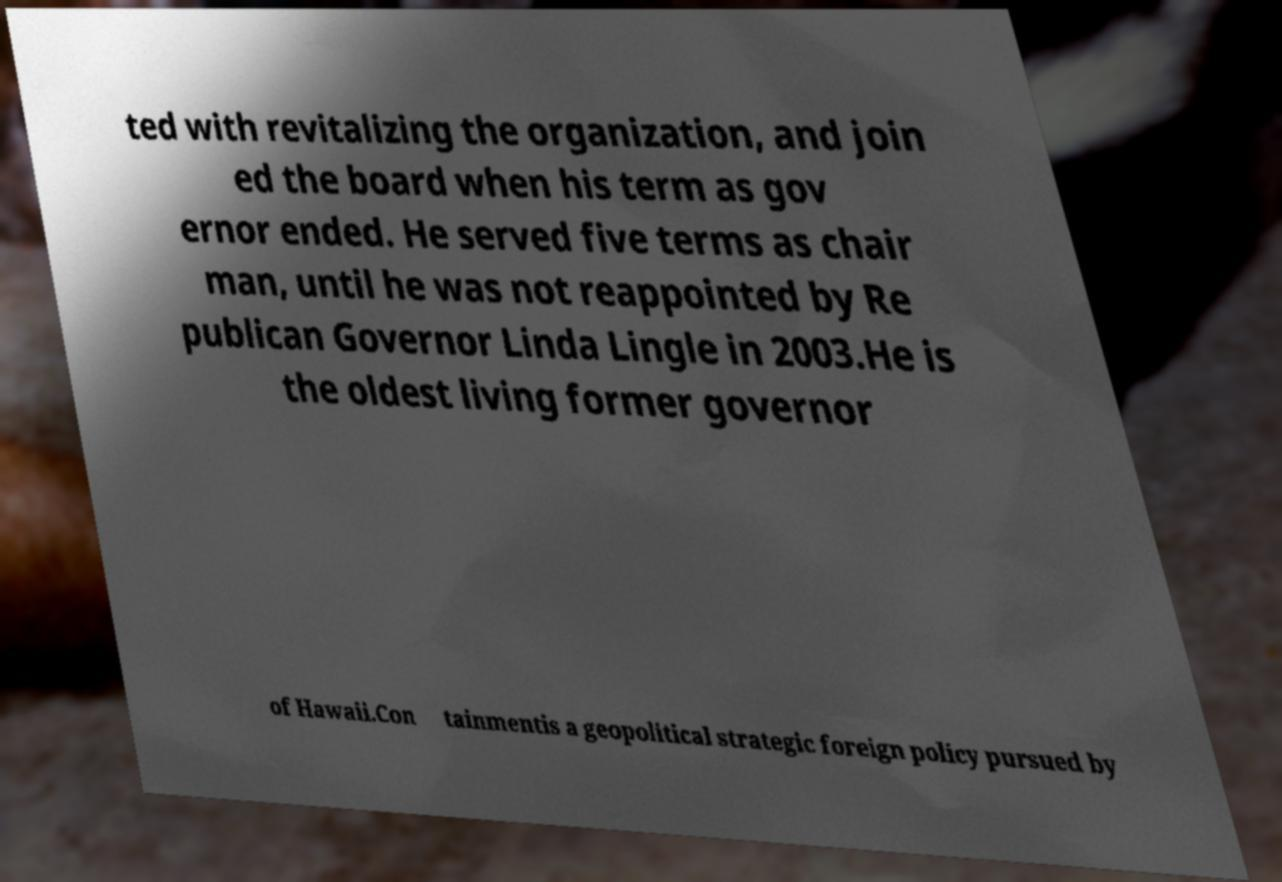For documentation purposes, I need the text within this image transcribed. Could you provide that? ted with revitalizing the organization, and join ed the board when his term as gov ernor ended. He served five terms as chair man, until he was not reappointed by Re publican Governor Linda Lingle in 2003.He is the oldest living former governor of Hawaii.Con tainmentis a geopolitical strategic foreign policy pursued by 